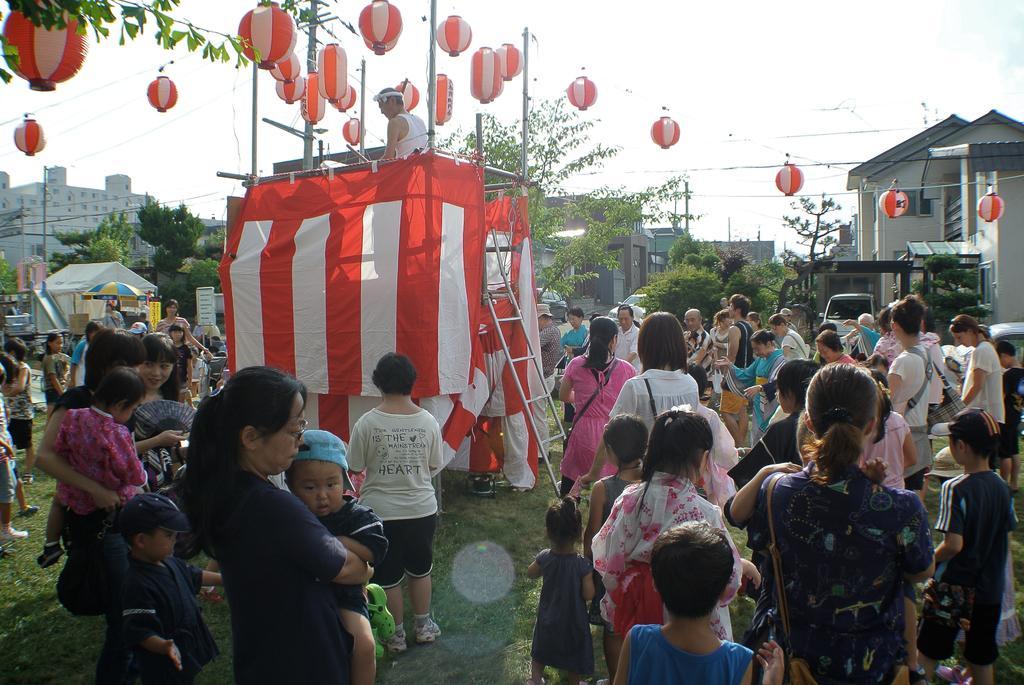In one or two sentences, can you explain what this image depicts? Here we can see few persons are standing and among them there are few persons are carrying bags on their shoulders and holding kids in their hands. In the background there are buildings,poles,trees,hoardings,tents,an umbrella,decorative balls hanging to the wires,ladder,vehicles and clouds in the sky. 